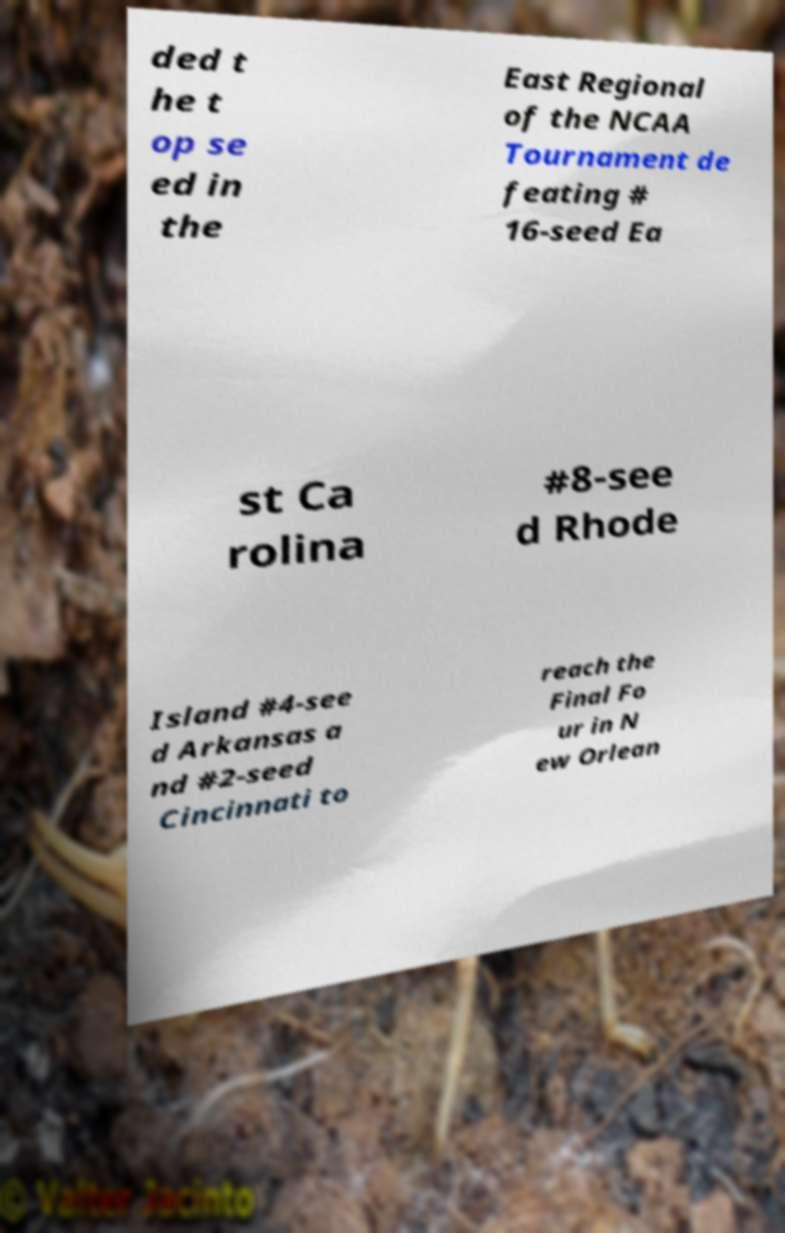I need the written content from this picture converted into text. Can you do that? ded t he t op se ed in the East Regional of the NCAA Tournament de feating # 16-seed Ea st Ca rolina #8-see d Rhode Island #4-see d Arkansas a nd #2-seed Cincinnati to reach the Final Fo ur in N ew Orlean 